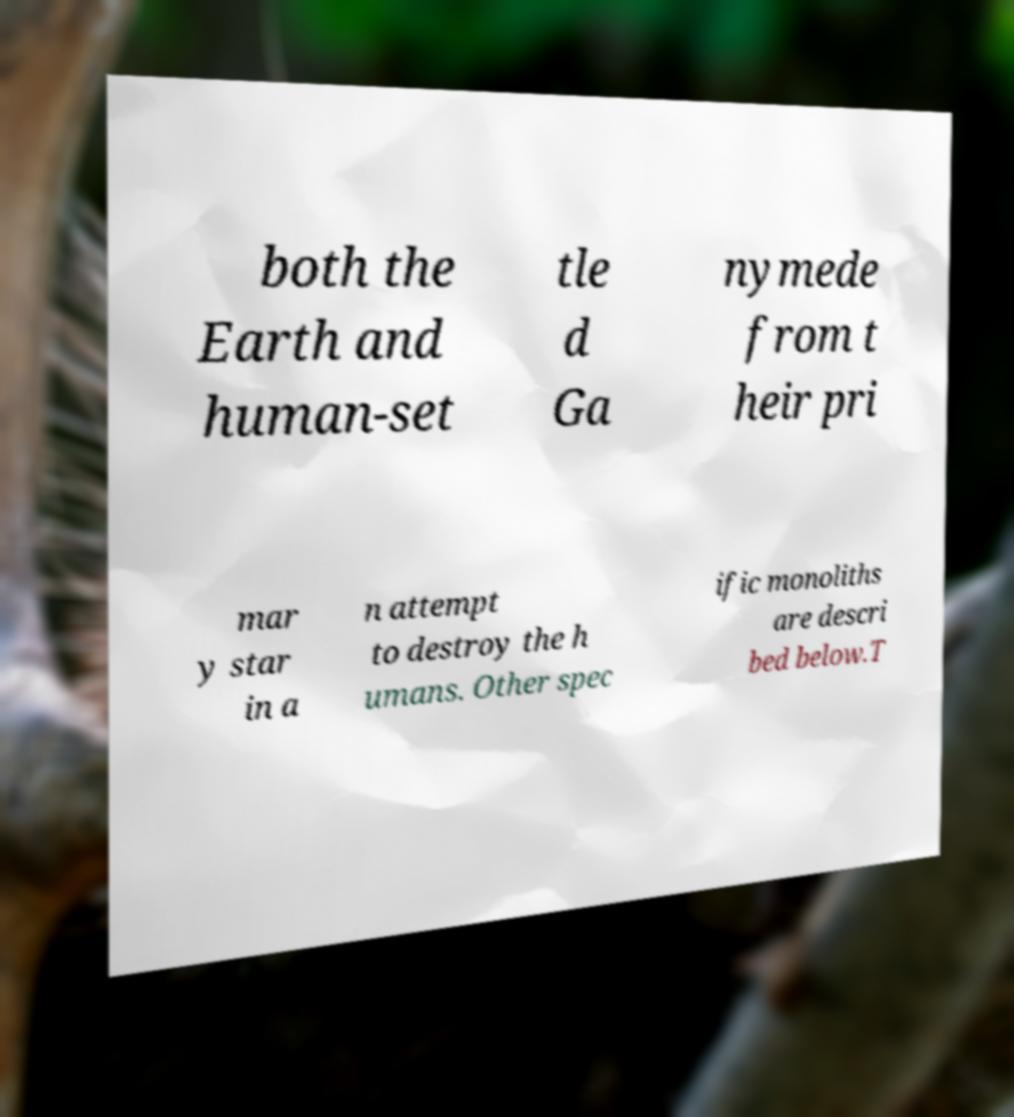For documentation purposes, I need the text within this image transcribed. Could you provide that? both the Earth and human-set tle d Ga nymede from t heir pri mar y star in a n attempt to destroy the h umans. Other spec ific monoliths are descri bed below.T 